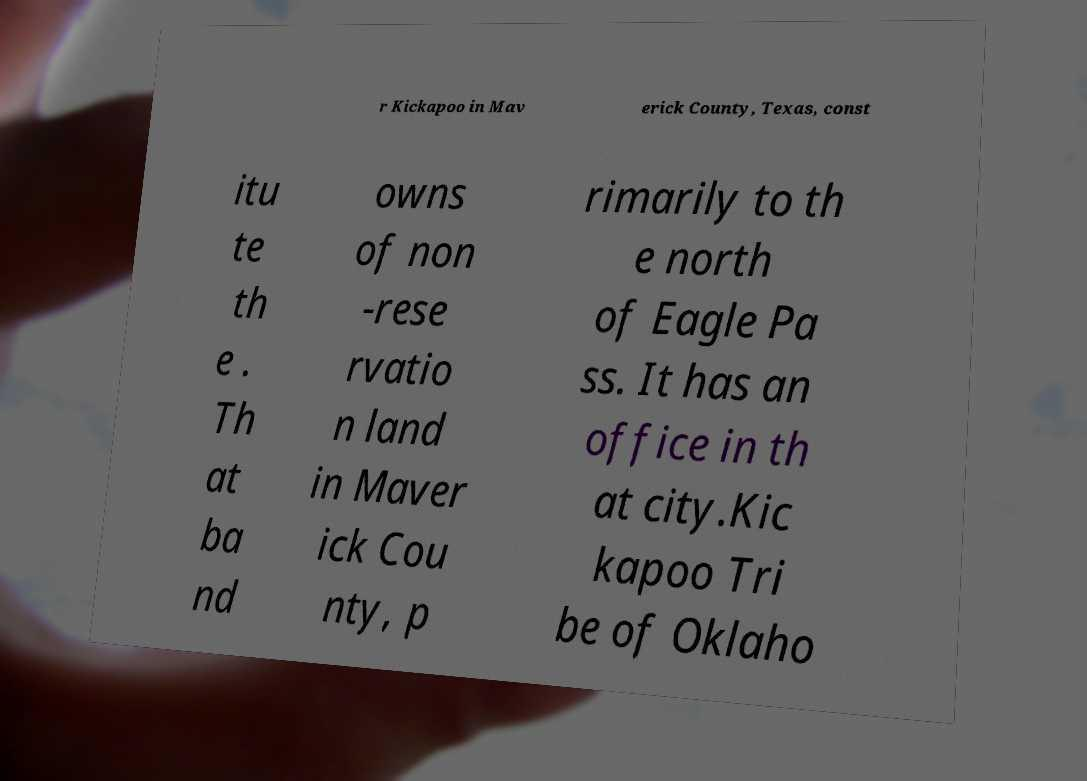I need the written content from this picture converted into text. Can you do that? r Kickapoo in Mav erick County, Texas, const itu te th e . Th at ba nd owns of non -rese rvatio n land in Maver ick Cou nty, p rimarily to th e north of Eagle Pa ss. It has an office in th at city.Kic kapoo Tri be of Oklaho 